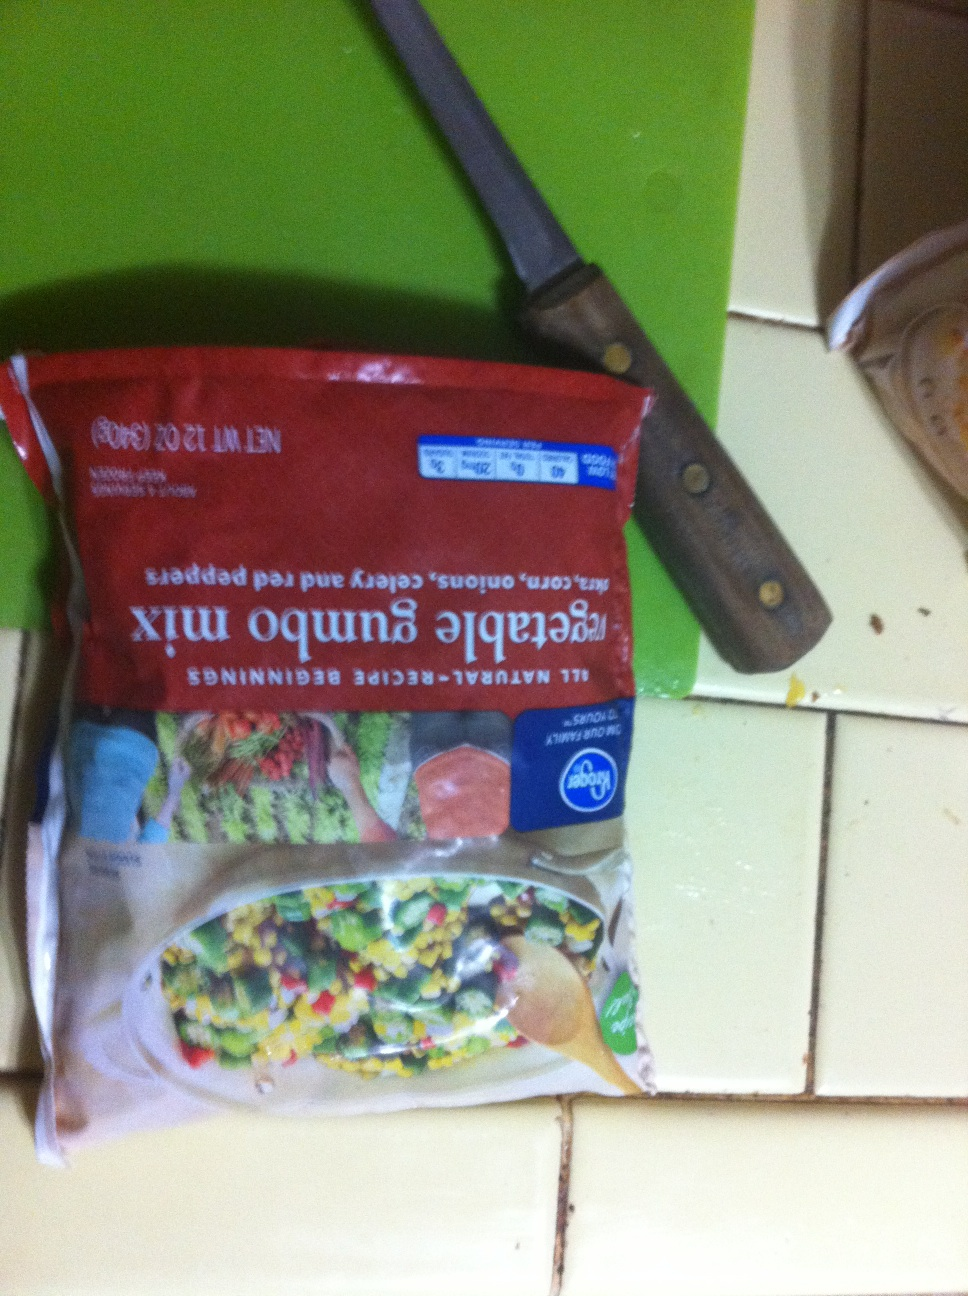What type of vegetables are these? Thank you. These are a blend of mixed vegetables commonly found in vegetable gumbo. The mix includes sweet corn, onions, celery, and red bell peppers. 